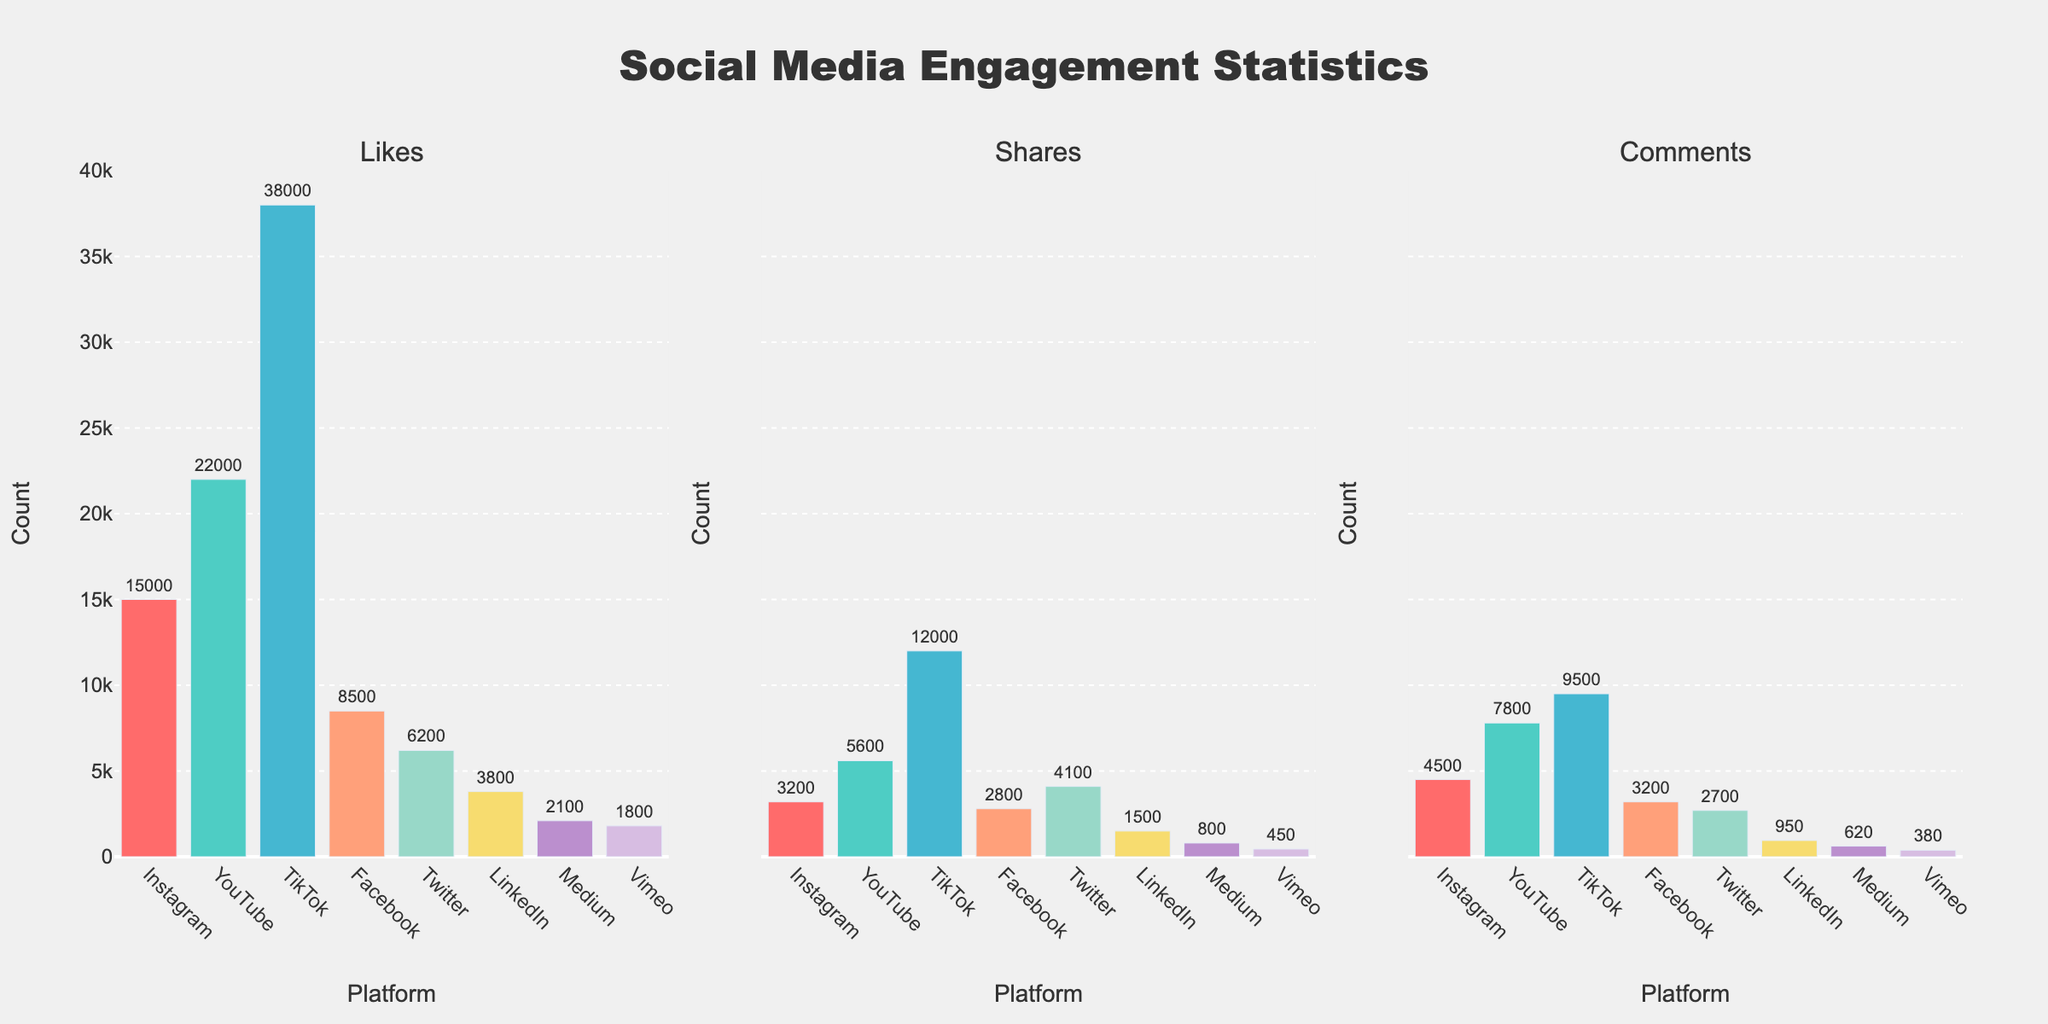What is the title of the figure? The title of the figure is usually displayed at the top of the chart. In this case, the title is centered and reads "Social Media Engagement Statistics".
Answer: Social Media Engagement Statistics Which platform received the most likes? By examining the height of the bars in the "Likes" subplot, the tallest bar represents the platform with the most likes. The TikTok bar is the tallest.
Answer: TikTok How many platforms received comments? The "Comments" subplot has bars representing each platform, count the number of bars present.
Answer: 8 Which platform has more shares: Twitter or Instagram? Look at the "Shares" subplot and compare the bar height for Twitter with that of Instagram. Twitter's bar is taller.
Answer: Twitter What are the total likes for YouTube and LinkedIn combined? Check the "Likes" subplot to find the likes for YouTube and LinkedIn. Add these values together: 22000 (YouTube) + 3800 (LinkedIn) = 25800.
Answer: 25800 Compare the number of shares and comments for Facebook. Which is higher? In the subplots for "Shares" and "Comments", find the values for Facebook. Shares are 2800 and Comments are 3200. Comments are higher.
Answer: Comments How many more likes does TikTok have compared to Facebook? Find the number of likes for TikTok and Facebook in the "Likes" subplot. Subtract Facebook's likes from TikTok's: 38000 - 8500 = 29500.
Answer: 29500 What is the average number of shares across all platforms? Sum the shares for all platforms and divide by the number of platforms. (3200 + 5600 + 12000 + 2800 + 4100 + 1500 + 800 + 450) / 8 = 3675.
Answer: 3675 Which platform has the lowest number of comments? Look at the "Comments" subplot to determine which bar is the shortest. The shortest bar represents Vimeo.
Answer: Vimeo 